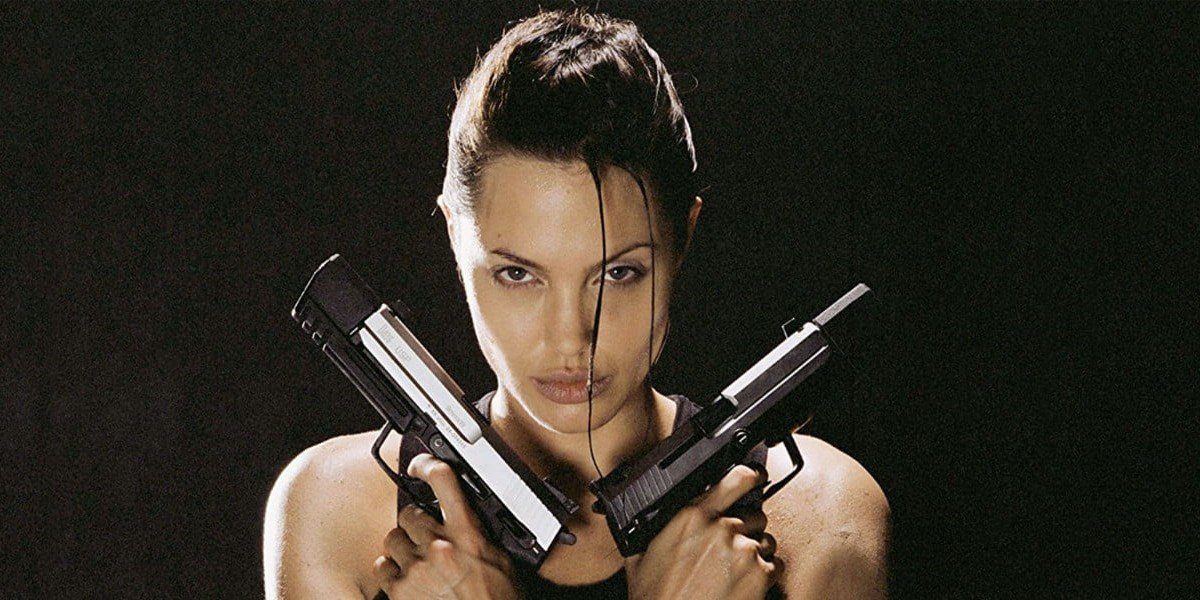What is the character in this image likely preparing for? The character, depicted in a fierce and determined stance, seems to be gearing up for a dangerous mission or a high-stakes adventure. With her guns crossed and ready, she looks prepared to face formidable adversaries or navigate through perilous terrains, embodying the essence of a fearless and skilled adventurer. 